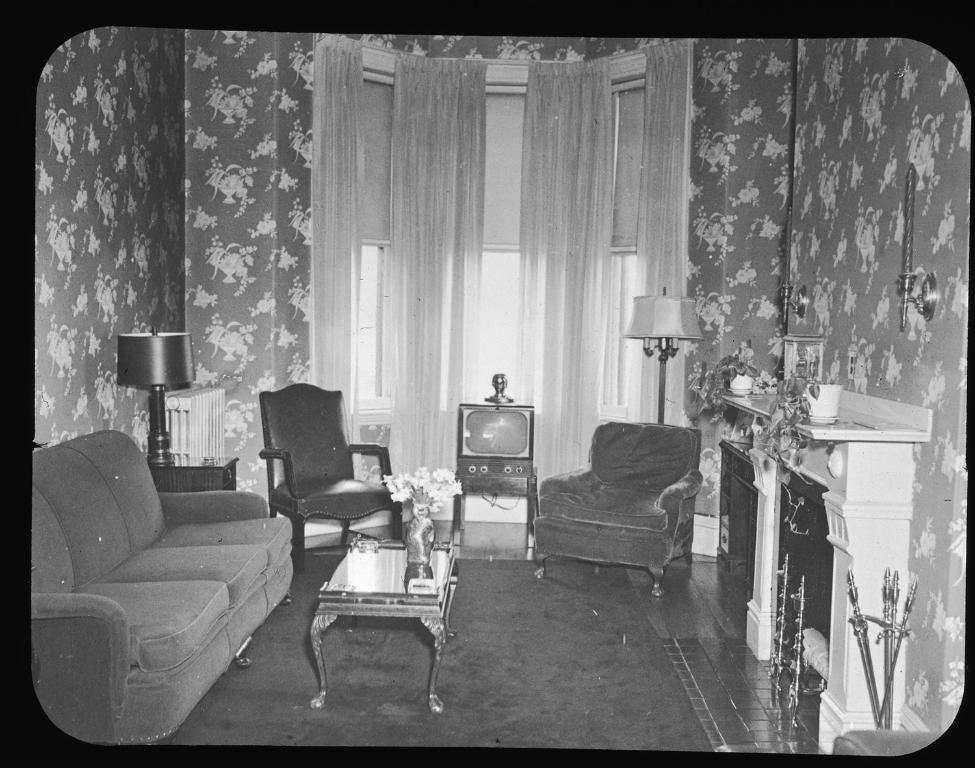How would you summarize this image in a sentence or two? This is a photograph in which we can see sofa,chair,lamp,window with curtain,TV,flower vase on the table,a candle stand,etc. 